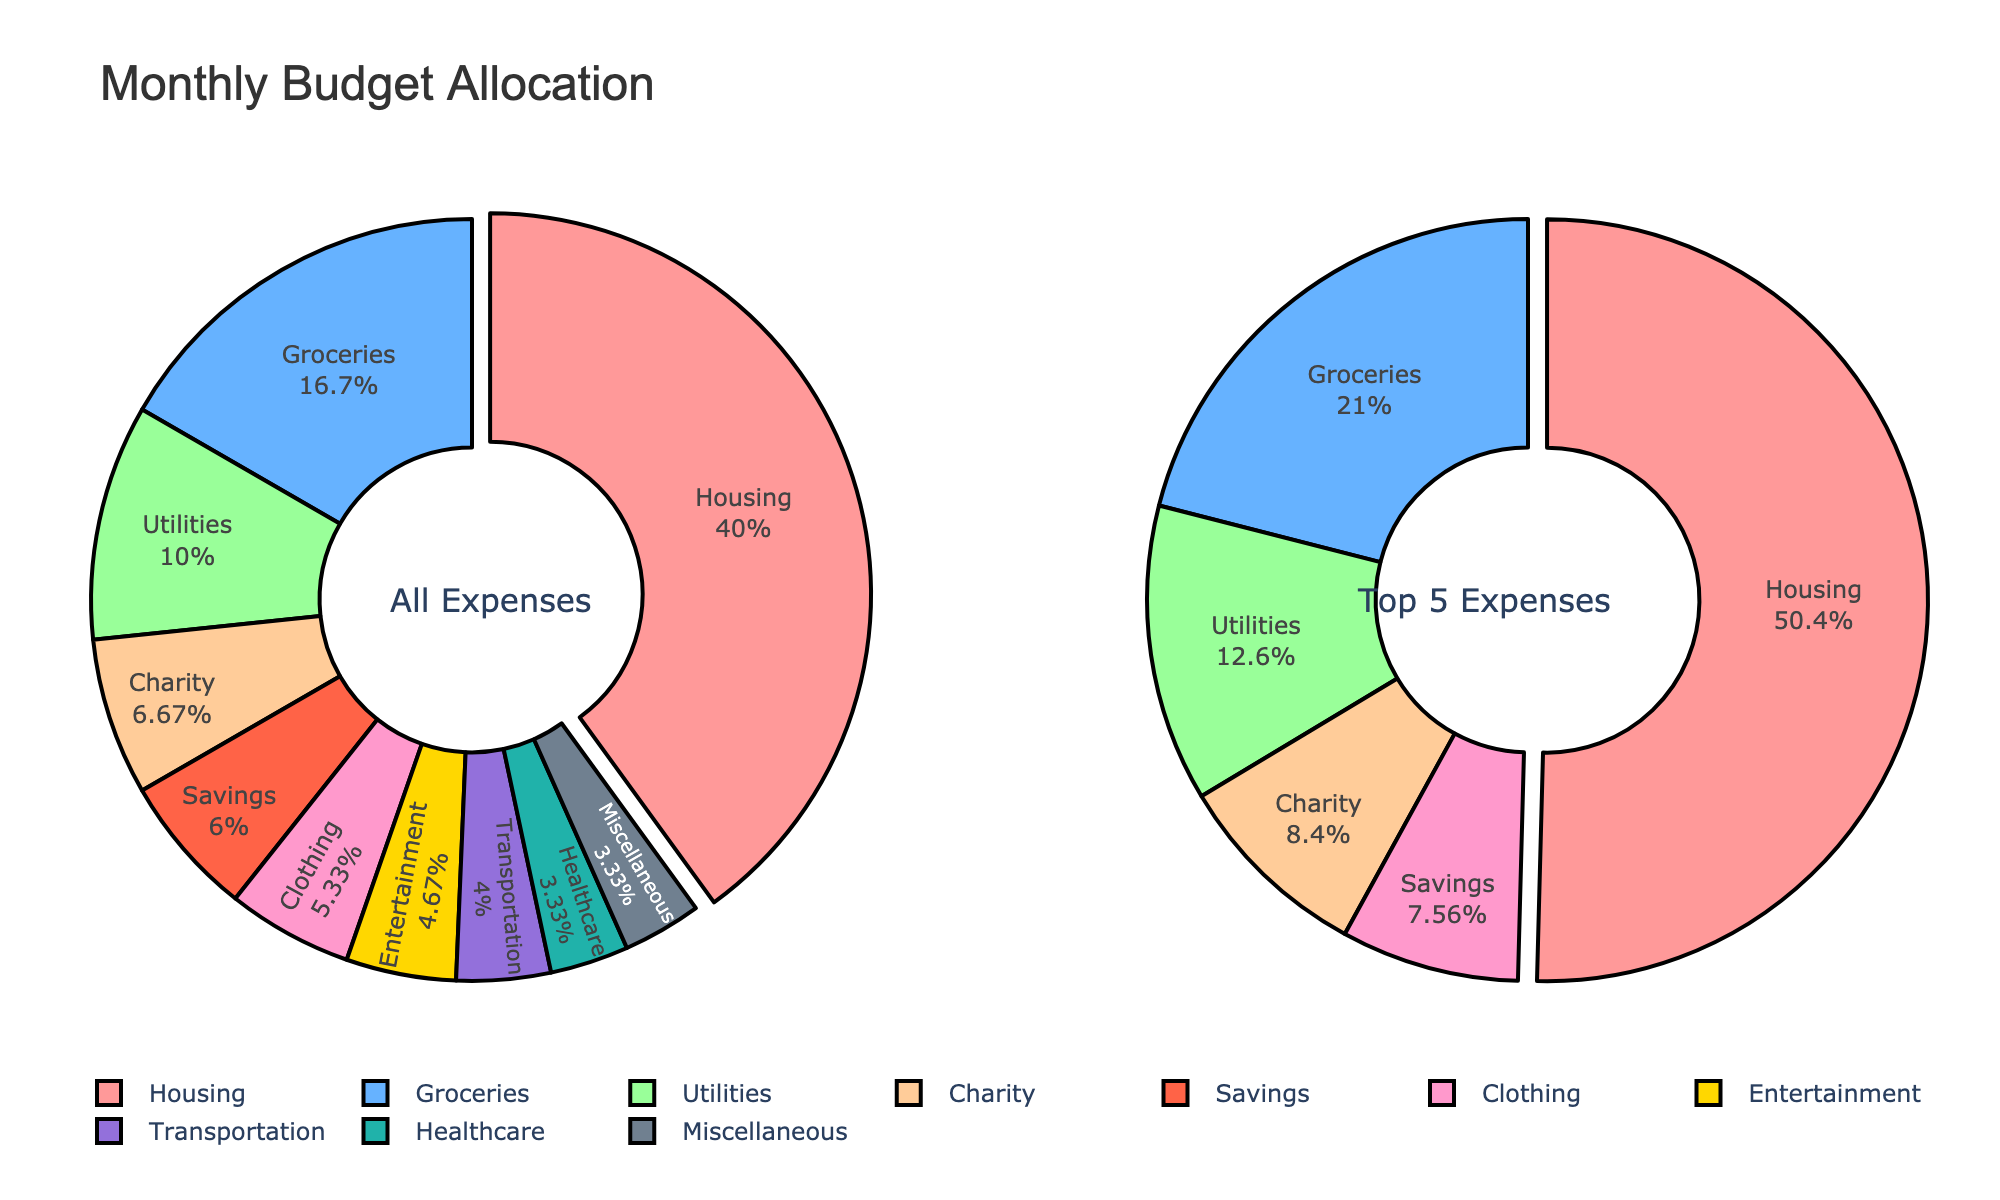What's the total monthly budget amount displayed in the figure? To find the total, sum all the expenses: 600 + 250 + 150 + 100 + 80 + 70 + 60 + 50 + 90 + 50 = 1500
Answer: 1500 Which expense category takes up the largest portion of the monthly budget? By visual inspection of the main pie chart, the largest slice belongs to Housing.
Answer: Housing What are the top two expense categories in terms of budget allocation? From the top 5 expenses pie chart, the two largest portions are Housing and Groceries.
Answer: Housing and Groceries How much more is spent on Housing compared to Entertainment? Compare the values for Housing and Entertainment: 600 (Housing) - 70 (Entertainment) = 530
Answer: 530 What percentage of the monthly budget is allocated to Charity? The portion of the main pie chart dedicated to Charity shows approximately 6.67%.
Answer: 6.67% What is the cumulative budget for Groceries, Clothing, and Healthcare? Add the amounts for Groceries, Clothing, and Healthcare: 250 + 80 + 50 = 380
Answer: 380 Which category in the top 5 expenses is allocated the least budget? In the top 5, the smallest allocation is for Charity.
Answer: Charity What are the categories shown in the "Top 5 Expenses" pie chart? The "Top 5 Expenses" pie chart includes Housing, Groceries, Utilities, Charity, and Clothing.
Answer: Housing, Groceries, Utilities, Charity, and Clothing Which categories contribute to less than 5% of the budget? From the main pie chart, categories with less than 5% are: Transportation, Healthcare, and Miscellaneous.
Answer: Transportation, Healthcare, Miscellaneous 